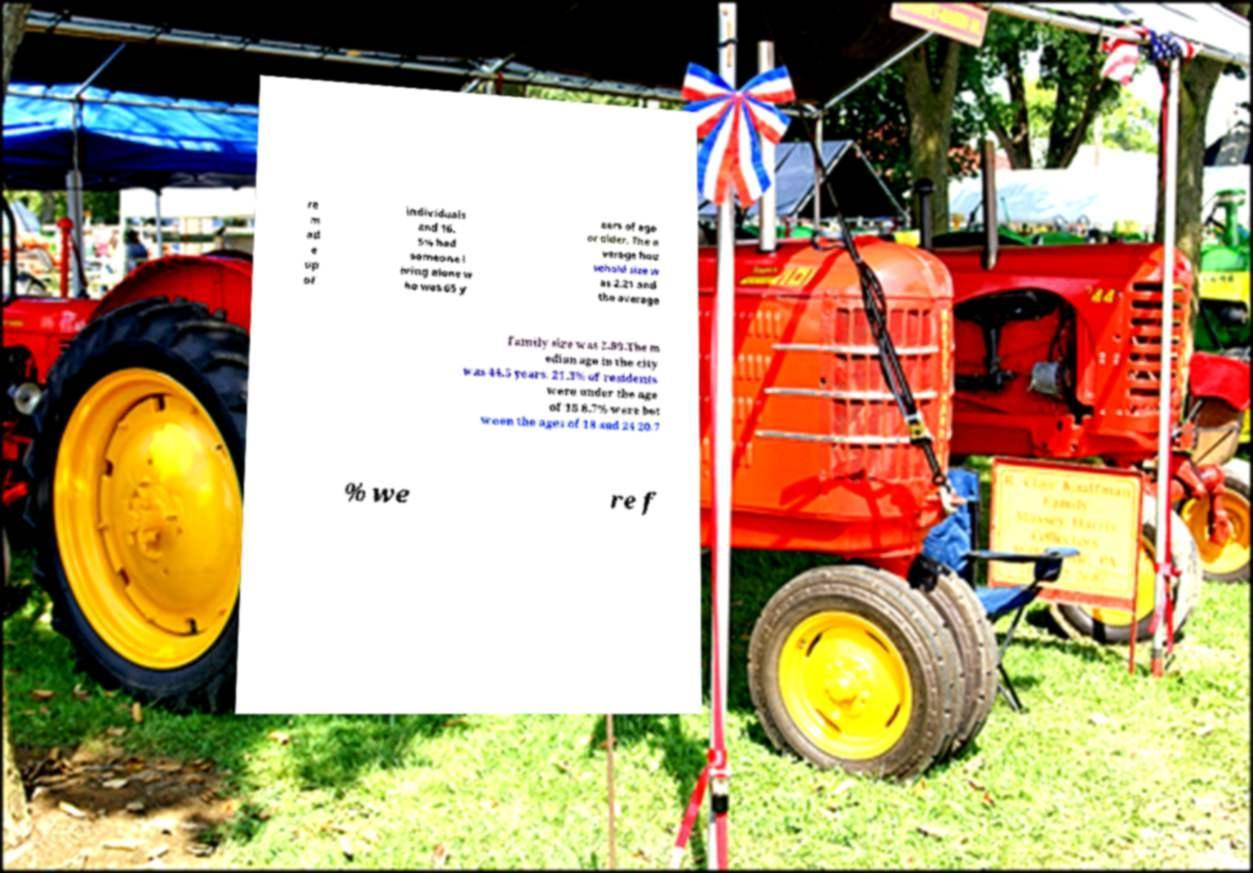Please read and relay the text visible in this image. What does it say? re m ad e up of individuals and 16. 5% had someone l iving alone w ho was 65 y ears of age or older. The a verage hou sehold size w as 2.21 and the average family size was 2.89.The m edian age in the city was 44.5 years. 21.3% of residents were under the age of 18 8.7% were bet ween the ages of 18 and 24 20.7 % we re f 